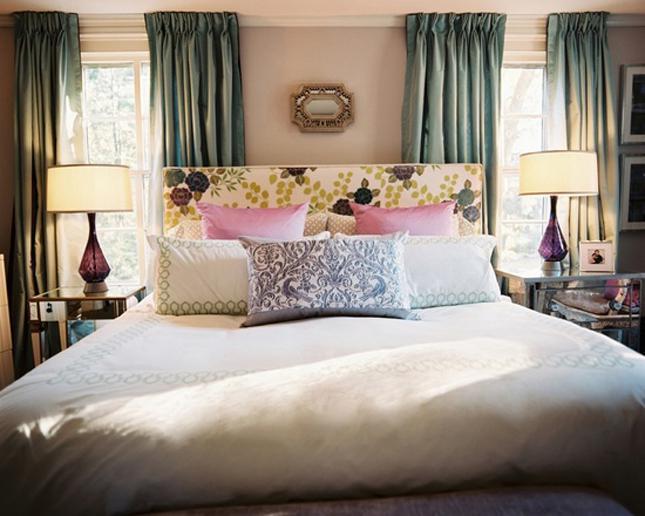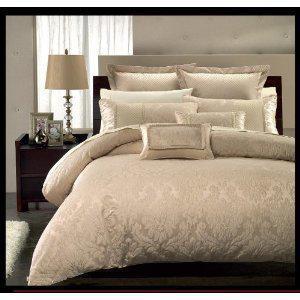The first image is the image on the left, the second image is the image on the right. Examine the images to the left and right. Is the description "There are exactly two table lamps in the image on the left." accurate? Answer yes or no. Yes. 